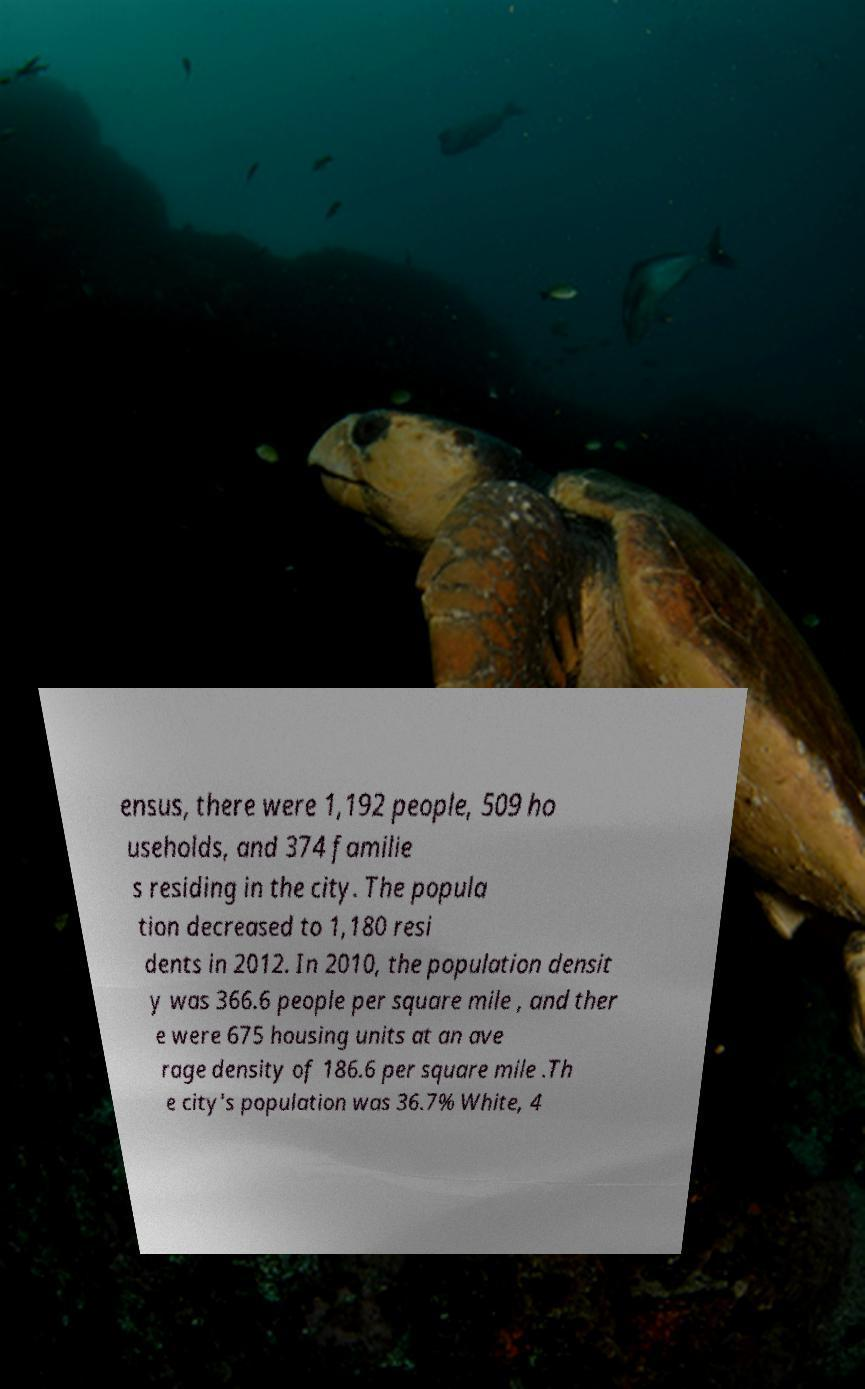Can you accurately transcribe the text from the provided image for me? ensus, there were 1,192 people, 509 ho useholds, and 374 familie s residing in the city. The popula tion decreased to 1,180 resi dents in 2012. In 2010, the population densit y was 366.6 people per square mile , and ther e were 675 housing units at an ave rage density of 186.6 per square mile .Th e city's population was 36.7% White, 4 